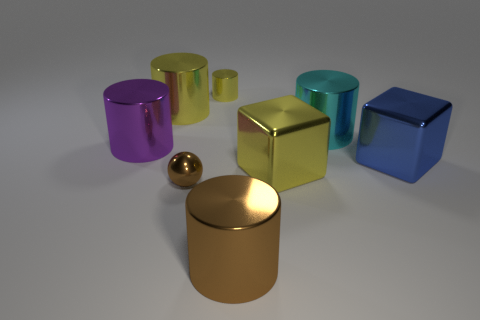Subtract all big yellow cylinders. How many cylinders are left? 4 Add 1 yellow shiny blocks. How many objects exist? 9 Subtract all purple cylinders. How many cylinders are left? 4 Subtract 3 cylinders. How many cylinders are left? 2 Subtract all red blocks. Subtract all gray balls. How many blocks are left? 2 Subtract all cyan cylinders. How many red spheres are left? 0 Subtract all big blue cubes. Subtract all large metal objects. How many objects are left? 1 Add 2 brown balls. How many brown balls are left? 3 Add 5 small purple matte blocks. How many small purple matte blocks exist? 5 Subtract 0 green cylinders. How many objects are left? 8 